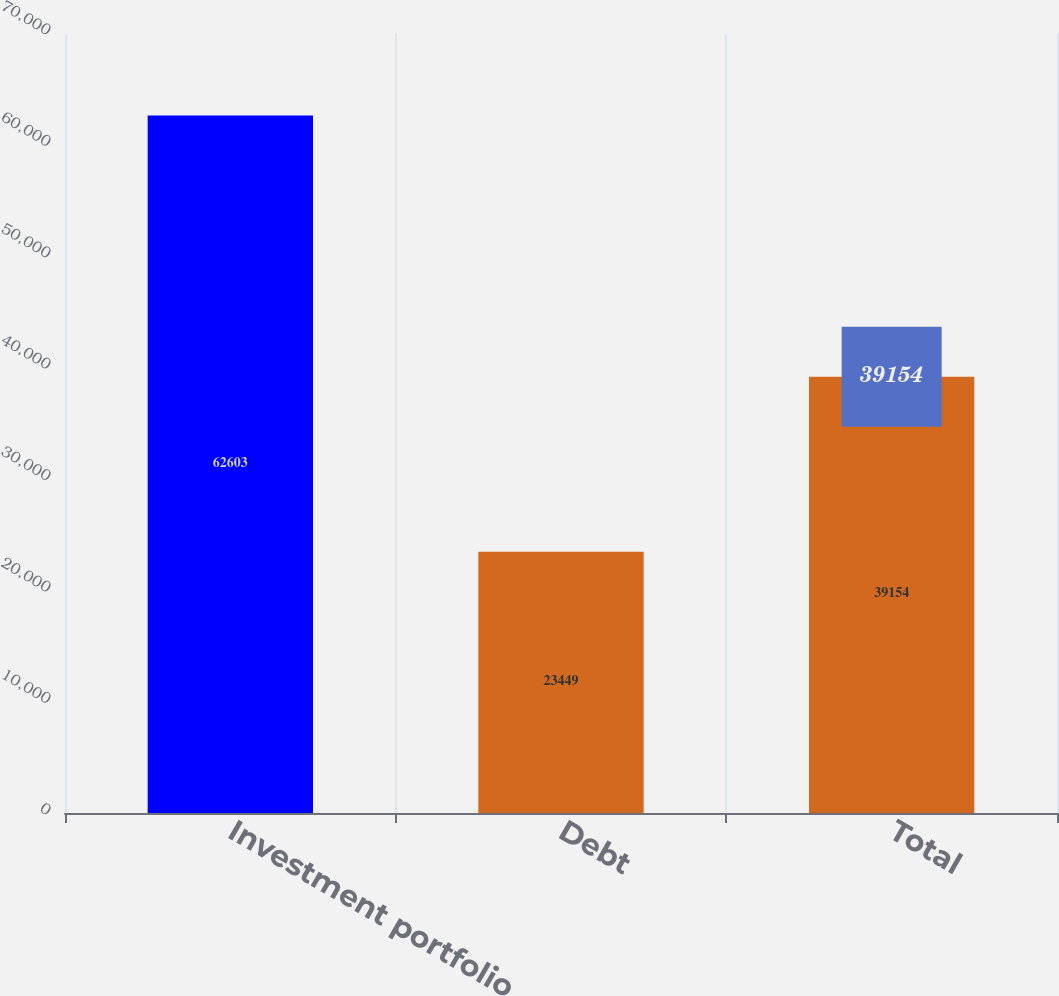<chart> <loc_0><loc_0><loc_500><loc_500><bar_chart><fcel>Investment portfolio<fcel>Debt<fcel>Total<nl><fcel>62603<fcel>23449<fcel>39154<nl></chart> 